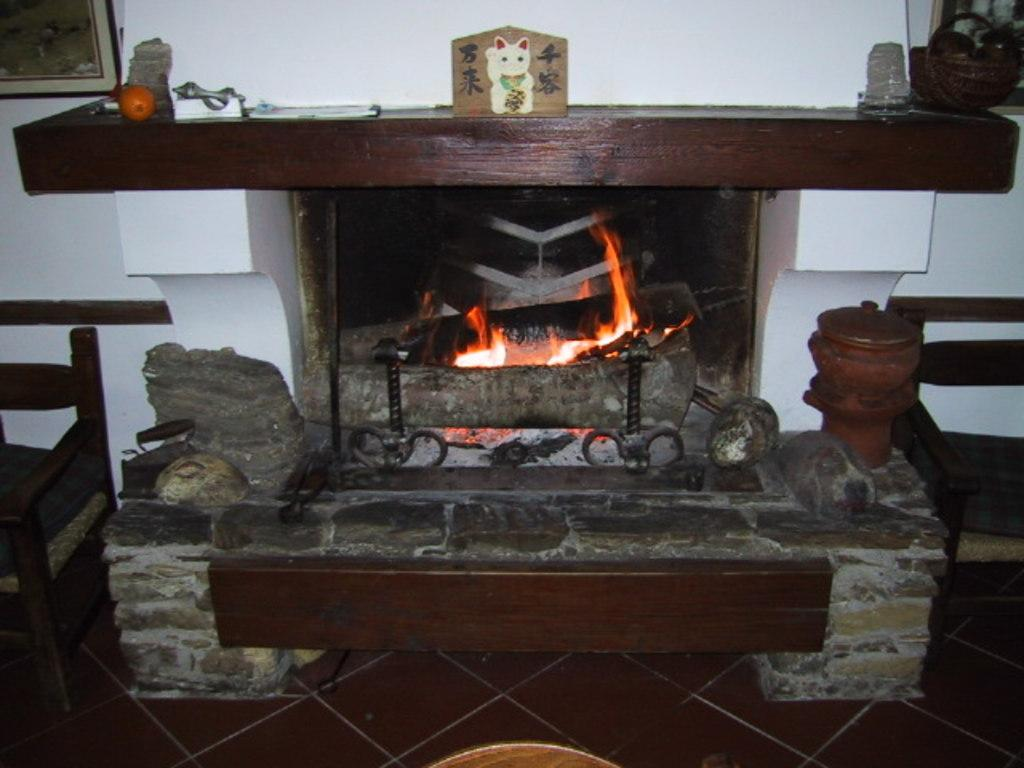How many chairs are on the floor in the image? There are two chairs on the floor in the image. What type of container is visible in the image? There is an iron box in the image. What type of natural material is present in the image? Stones are present in the image. What feature is typically used for heating in a room? There is a fireplace in the image. What type of decorative items can be seen on the wall? There are frames on the wall. What type of container is visible in the image? There is a basket in the image. What other unspecified objects are present in the image? There are some unspecified objects in the image. What type of produce is being harvested in the image? There is no produce or harvesting activity present in the image. What type of song is being sung in the image? There is no singing or song present in the image. What type of arithmetic problem is being solved in the image? There is no arithmetic problem or solving activity present in the image. 